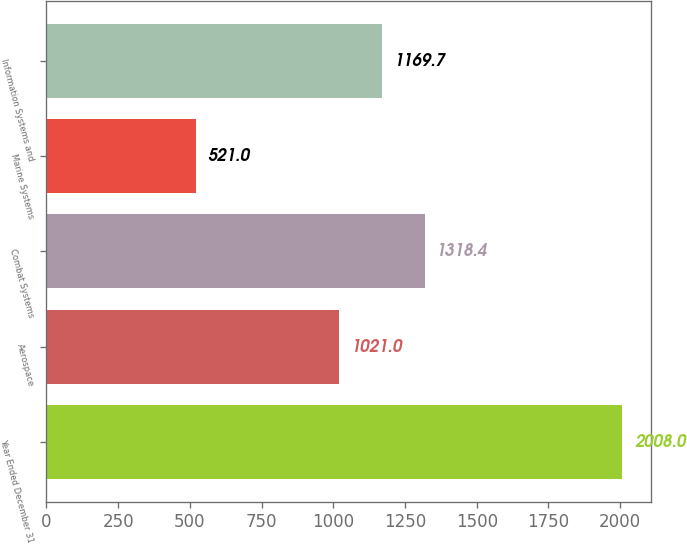<chart> <loc_0><loc_0><loc_500><loc_500><bar_chart><fcel>Year Ended December 31<fcel>Aerospace<fcel>Combat Systems<fcel>Marine Systems<fcel>Information Systems and<nl><fcel>2008<fcel>1021<fcel>1318.4<fcel>521<fcel>1169.7<nl></chart> 